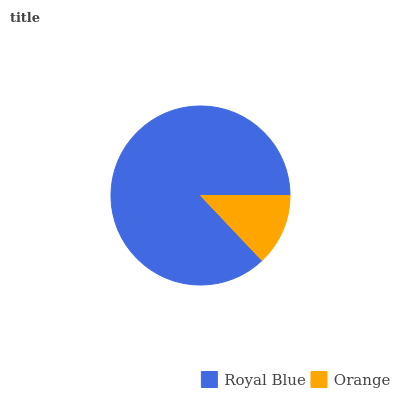Is Orange the minimum?
Answer yes or no. Yes. Is Royal Blue the maximum?
Answer yes or no. Yes. Is Orange the maximum?
Answer yes or no. No. Is Royal Blue greater than Orange?
Answer yes or no. Yes. Is Orange less than Royal Blue?
Answer yes or no. Yes. Is Orange greater than Royal Blue?
Answer yes or no. No. Is Royal Blue less than Orange?
Answer yes or no. No. Is Royal Blue the high median?
Answer yes or no. Yes. Is Orange the low median?
Answer yes or no. Yes. Is Orange the high median?
Answer yes or no. No. Is Royal Blue the low median?
Answer yes or no. No. 